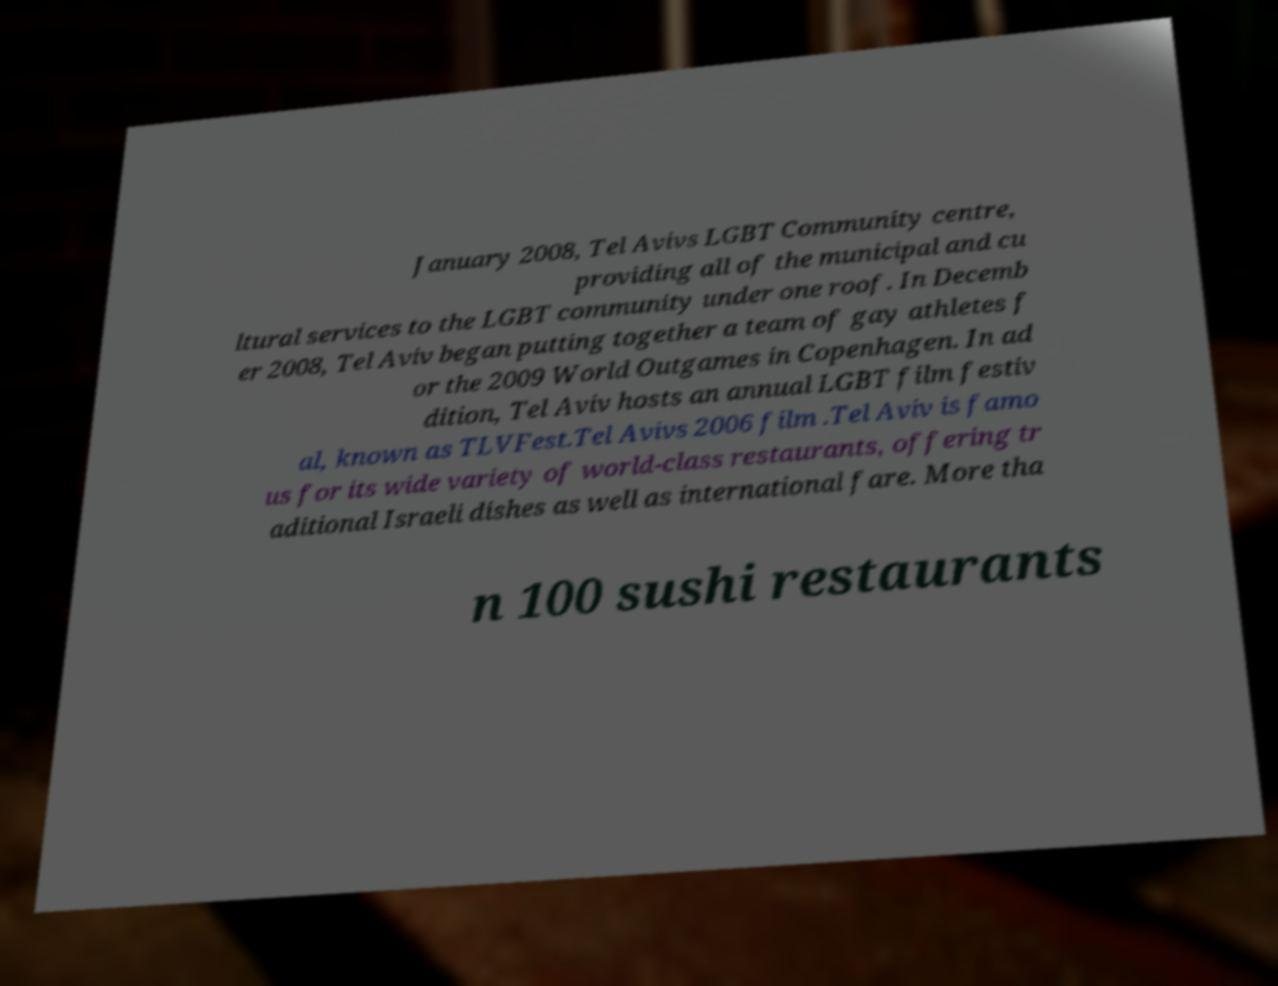What messages or text are displayed in this image? I need them in a readable, typed format. January 2008, Tel Avivs LGBT Community centre, providing all of the municipal and cu ltural services to the LGBT community under one roof. In Decemb er 2008, Tel Aviv began putting together a team of gay athletes f or the 2009 World Outgames in Copenhagen. In ad dition, Tel Aviv hosts an annual LGBT film festiv al, known as TLVFest.Tel Avivs 2006 film .Tel Aviv is famo us for its wide variety of world-class restaurants, offering tr aditional Israeli dishes as well as international fare. More tha n 100 sushi restaurants 